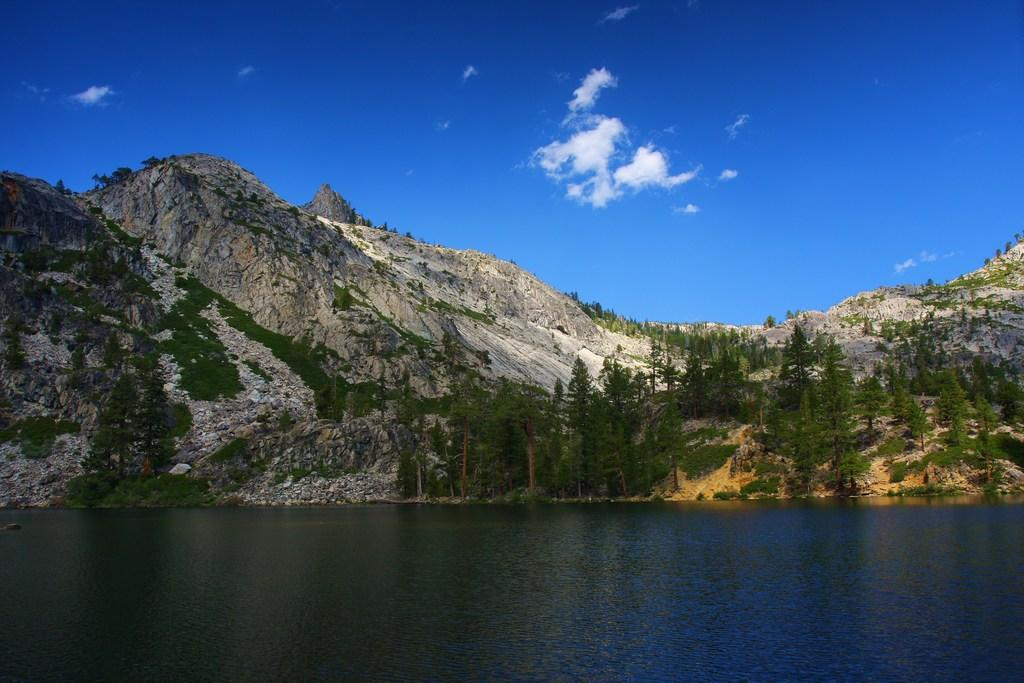What is the primary element visible in the image? There is water in the image. What can be seen in the distance behind the water? There are trees and mountains in the background of the image. What is the color of the sky in the image? The sky is blue in color. How many toes can be seen in the image? There are no toes visible in the image. What is the desire of the trees in the background? The trees in the background do not have desires, as they are inanimate objects. 